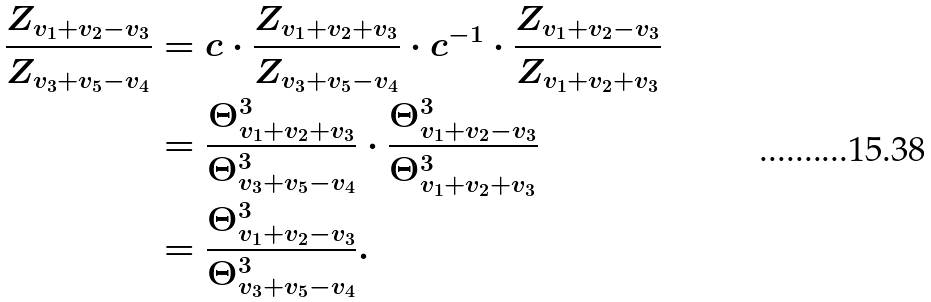<formula> <loc_0><loc_0><loc_500><loc_500>\frac { Z _ { v _ { 1 } + v _ { 2 } - v _ { 3 } } } { Z _ { v _ { 3 } + v _ { 5 } - v _ { 4 } } } & = c \cdot \frac { Z _ { v _ { 1 } + v _ { 2 } + v _ { 3 } } } { Z _ { v _ { 3 } + v _ { 5 } - v _ { 4 } } } \cdot c ^ { - 1 } \cdot \frac { Z _ { v _ { 1 } + v _ { 2 } - v _ { 3 } } } { Z _ { v _ { 1 } + v _ { 2 } + v _ { 3 } } } \\ & = \frac { \Theta _ { v _ { 1 } + v _ { 2 } + v _ { 3 } } ^ { 3 } } { \Theta _ { v _ { 3 } + v _ { 5 } - v _ { 4 } } ^ { 3 } } \cdot \frac { \Theta _ { v _ { 1 } + v _ { 2 } - v _ { 3 } } ^ { 3 } } { \Theta _ { v _ { 1 } + v _ { 2 } + v _ { 3 } } ^ { 3 } } \\ & = \frac { \Theta _ { v _ { 1 } + v _ { 2 } - v _ { 3 } } ^ { 3 } } { \Theta _ { v _ { 3 } + v _ { 5 } - v _ { 4 } } ^ { 3 } } .</formula> 